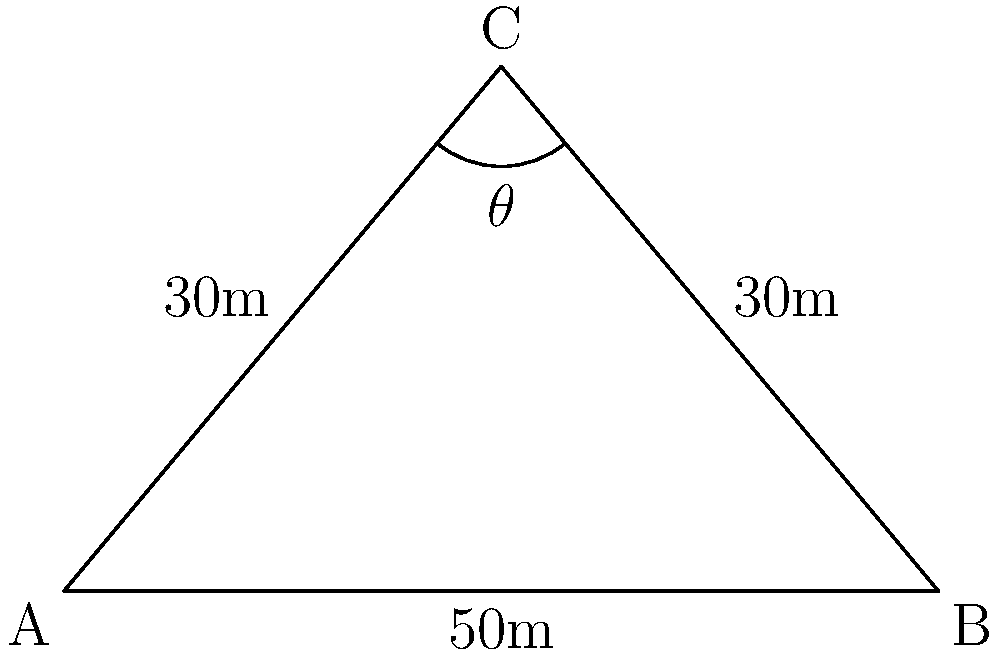A surveillance drone is hovering at point C, 30 meters above the ground. It needs to monitor two points (A and B) on the ground that are 50 meters apart. What is the viewing angle $\theta$ required for the drone's camera to capture both points? To solve this problem, we'll use the law of cosines. Here's the step-by-step solution:

1) We have a triangle ABC where:
   AB = 50m (ground distance)
   AC = BC = 30m (drone's height)

2) The law of cosines states:
   $c^2 = a^2 + b^2 - 2ab \cos(C)$

   Where C is the angle we're looking for ($\theta$), and c is the side opposite to this angle (AB).

3) Substituting our values:
   $50^2 = 30^2 + 30^2 - 2(30)(30) \cos(\theta)$

4) Simplify:
   $2500 = 900 + 900 - 1800 \cos(\theta)$
   $2500 = 1800 - 1800 \cos(\theta)$

5) Subtract 1800 from both sides:
   $700 = -1800 \cos(\theta)$

6) Divide both sides by -1800:
   $-\frac{7}{18} = \cos(\theta)$

7) Take the inverse cosine (arccos) of both sides:
   $\theta = \arccos(-\frac{7}{18})$

8) Calculate:
   $\theta \approx 2.214$ radians

9) Convert to degrees:
   $\theta \approx 126.87°$

Therefore, the viewing angle required for the drone's camera is approximately 126.87°.
Answer: 126.87° 